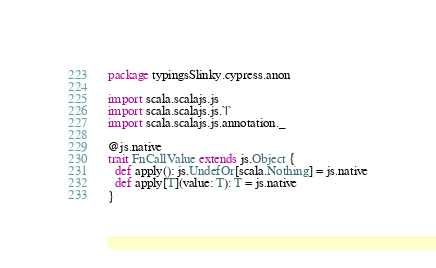<code> <loc_0><loc_0><loc_500><loc_500><_Scala_>package typingsSlinky.cypress.anon

import scala.scalajs.js
import scala.scalajs.js.`|`
import scala.scalajs.js.annotation._

@js.native
trait FnCallValue extends js.Object {
  def apply(): js.UndefOr[scala.Nothing] = js.native
  def apply[T](value: T): T = js.native
}

</code> 